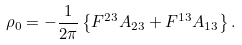<formula> <loc_0><loc_0><loc_500><loc_500>\rho _ { 0 } = - \frac { 1 } { 2 \pi } \left \{ F ^ { 2 3 } A _ { 2 3 } + F ^ { 1 3 } A _ { 1 3 } \right \} .</formula> 